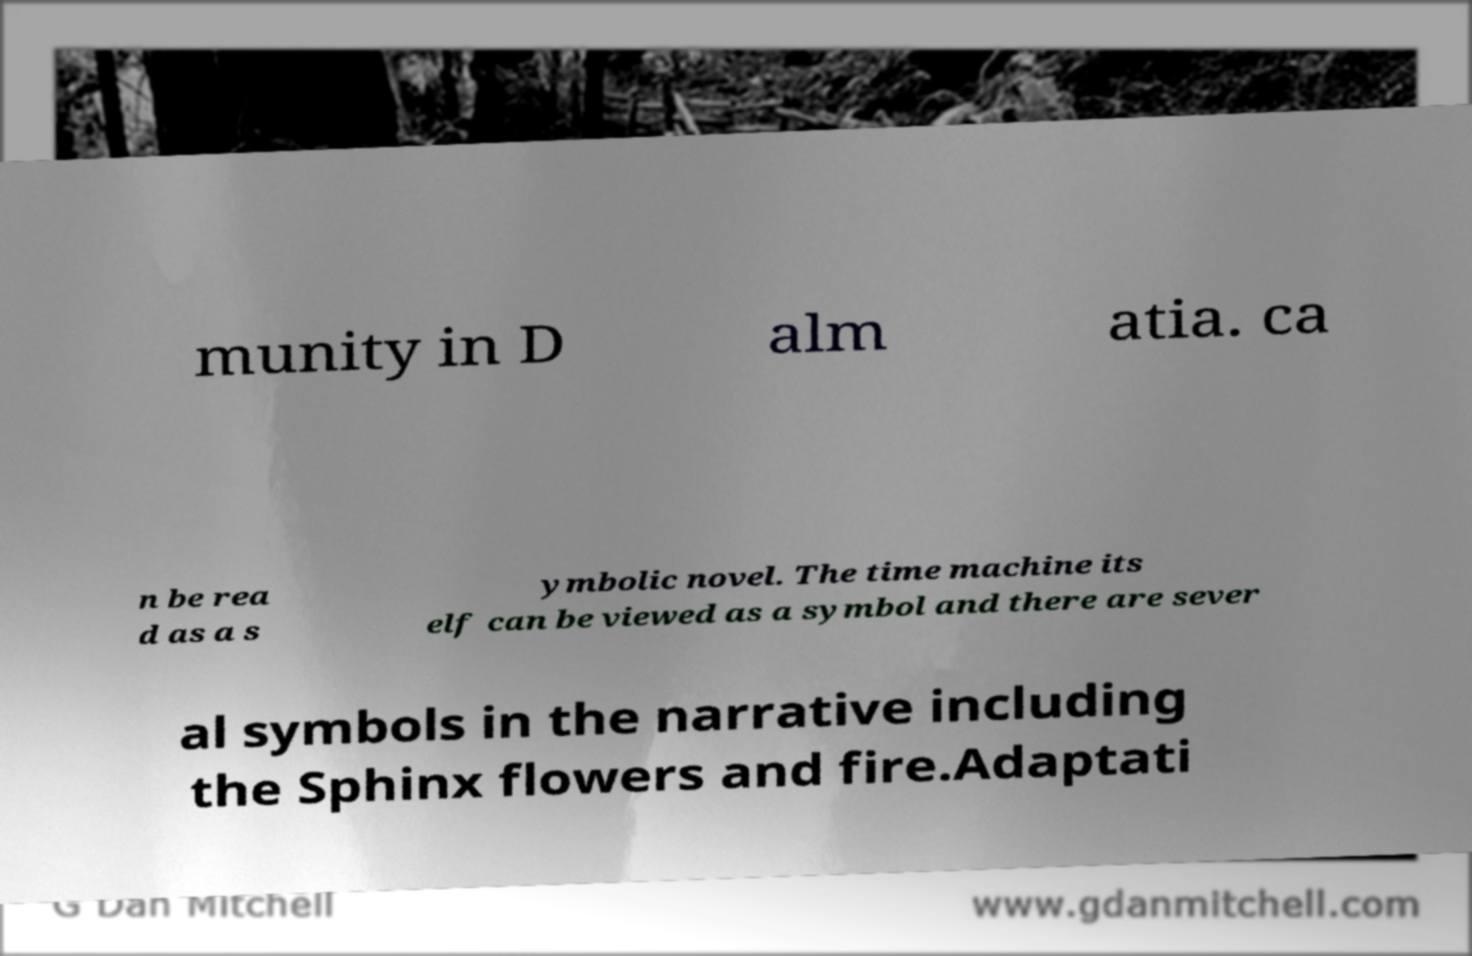Could you assist in decoding the text presented in this image and type it out clearly? munity in D alm atia. ca n be rea d as a s ymbolic novel. The time machine its elf can be viewed as a symbol and there are sever al symbols in the narrative including the Sphinx flowers and fire.Adaptati 